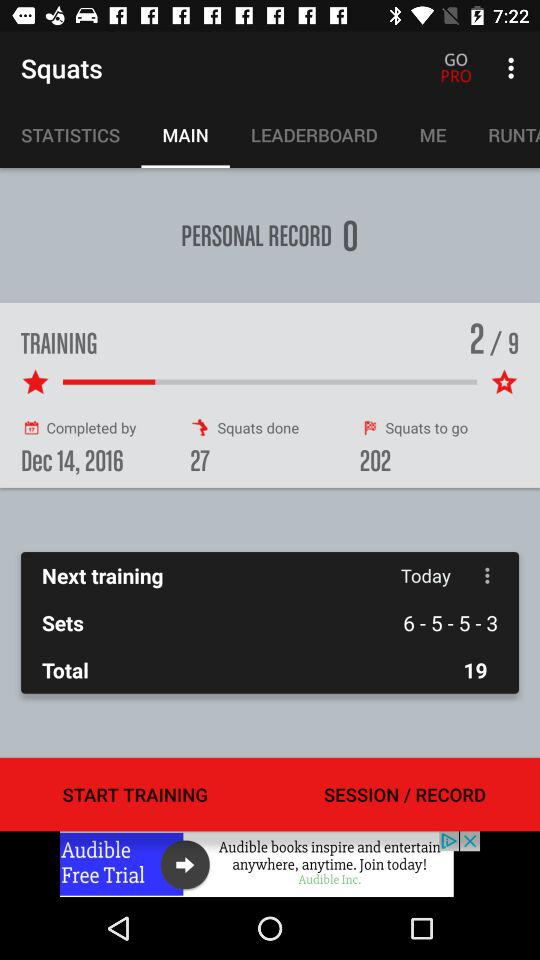How many total trainings are there? There are a total of 9 trainings. 